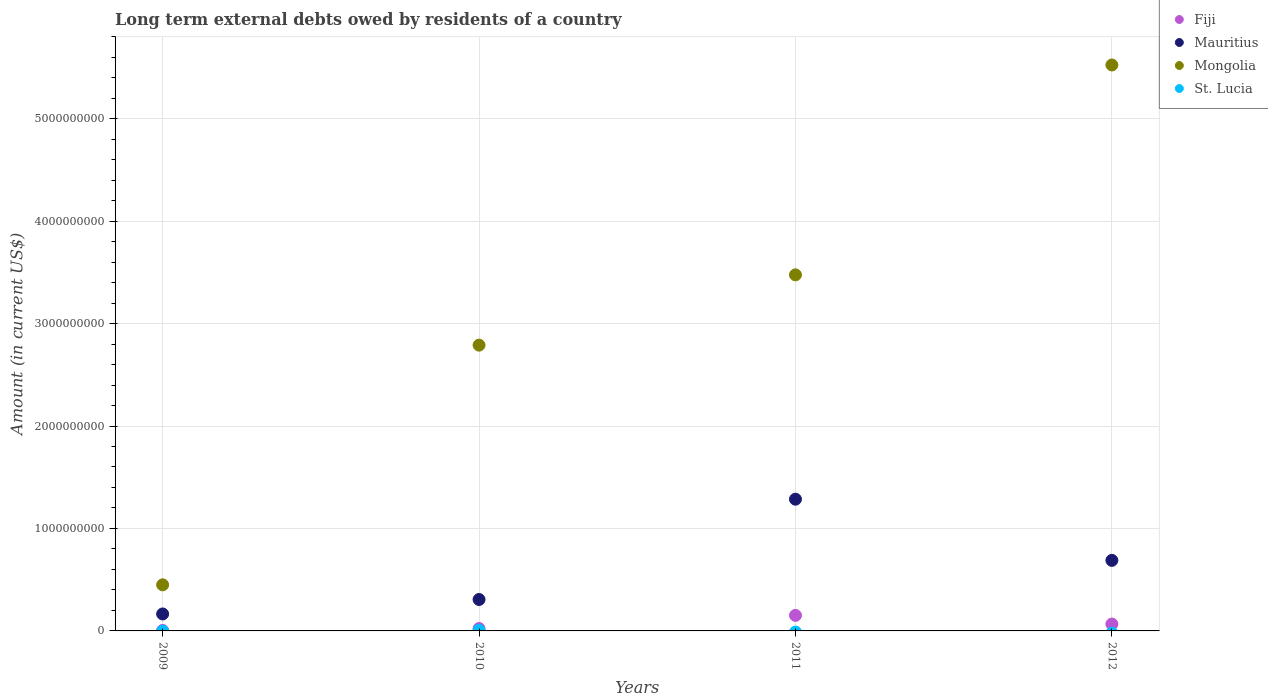How many different coloured dotlines are there?
Provide a succinct answer. 4. Is the number of dotlines equal to the number of legend labels?
Give a very brief answer. No. Across all years, what is the maximum amount of long-term external debts owed by residents in St. Lucia?
Your answer should be very brief. 6.51e+06. Across all years, what is the minimum amount of long-term external debts owed by residents in Mongolia?
Offer a very short reply. 4.50e+08. In which year was the amount of long-term external debts owed by residents in St. Lucia maximum?
Your answer should be very brief. 2010. What is the total amount of long-term external debts owed by residents in Fiji in the graph?
Keep it short and to the point. 2.47e+08. What is the difference between the amount of long-term external debts owed by residents in Fiji in 2009 and that in 2012?
Offer a terse response. -6.22e+07. What is the difference between the amount of long-term external debts owed by residents in St. Lucia in 2011 and the amount of long-term external debts owed by residents in Mauritius in 2009?
Keep it short and to the point. -1.65e+08. What is the average amount of long-term external debts owed by residents in St. Lucia per year?
Offer a terse response. 1.63e+06. In the year 2009, what is the difference between the amount of long-term external debts owed by residents in Fiji and amount of long-term external debts owed by residents in Mauritius?
Your response must be concise. -1.61e+08. In how many years, is the amount of long-term external debts owed by residents in Mauritius greater than 2000000000 US$?
Your response must be concise. 0. What is the ratio of the amount of long-term external debts owed by residents in Mauritius in 2011 to that in 2012?
Keep it short and to the point. 1.87. Is the difference between the amount of long-term external debts owed by residents in Fiji in 2009 and 2010 greater than the difference between the amount of long-term external debts owed by residents in Mauritius in 2009 and 2010?
Provide a succinct answer. Yes. What is the difference between the highest and the second highest amount of long-term external debts owed by residents in Mauritius?
Provide a succinct answer. 5.97e+08. What is the difference between the highest and the lowest amount of long-term external debts owed by residents in Mongolia?
Your answer should be very brief. 5.07e+09. In how many years, is the amount of long-term external debts owed by residents in St. Lucia greater than the average amount of long-term external debts owed by residents in St. Lucia taken over all years?
Your answer should be compact. 1. Is the sum of the amount of long-term external debts owed by residents in Mongolia in 2010 and 2012 greater than the maximum amount of long-term external debts owed by residents in Fiji across all years?
Your response must be concise. Yes. Is it the case that in every year, the sum of the amount of long-term external debts owed by residents in St. Lucia and amount of long-term external debts owed by residents in Mongolia  is greater than the amount of long-term external debts owed by residents in Fiji?
Ensure brevity in your answer.  Yes. Does the amount of long-term external debts owed by residents in St. Lucia monotonically increase over the years?
Your answer should be very brief. No. Is the amount of long-term external debts owed by residents in St. Lucia strictly less than the amount of long-term external debts owed by residents in Fiji over the years?
Provide a short and direct response. Yes. How many dotlines are there?
Your answer should be very brief. 4. How many years are there in the graph?
Give a very brief answer. 4. How many legend labels are there?
Your answer should be compact. 4. What is the title of the graph?
Your answer should be compact. Long term external debts owed by residents of a country. Does "Guyana" appear as one of the legend labels in the graph?
Ensure brevity in your answer.  No. What is the label or title of the X-axis?
Provide a short and direct response. Years. What is the Amount (in current US$) of Fiji in 2009?
Provide a succinct answer. 4.86e+06. What is the Amount (in current US$) of Mauritius in 2009?
Give a very brief answer. 1.65e+08. What is the Amount (in current US$) of Mongolia in 2009?
Offer a very short reply. 4.50e+08. What is the Amount (in current US$) in Fiji in 2010?
Keep it short and to the point. 2.35e+07. What is the Amount (in current US$) of Mauritius in 2010?
Keep it short and to the point. 3.07e+08. What is the Amount (in current US$) in Mongolia in 2010?
Your answer should be very brief. 2.79e+09. What is the Amount (in current US$) in St. Lucia in 2010?
Give a very brief answer. 6.51e+06. What is the Amount (in current US$) of Fiji in 2011?
Provide a short and direct response. 1.52e+08. What is the Amount (in current US$) of Mauritius in 2011?
Provide a succinct answer. 1.29e+09. What is the Amount (in current US$) in Mongolia in 2011?
Provide a succinct answer. 3.48e+09. What is the Amount (in current US$) of St. Lucia in 2011?
Make the answer very short. 0. What is the Amount (in current US$) of Fiji in 2012?
Make the answer very short. 6.71e+07. What is the Amount (in current US$) in Mauritius in 2012?
Provide a succinct answer. 6.89e+08. What is the Amount (in current US$) of Mongolia in 2012?
Your answer should be very brief. 5.52e+09. What is the Amount (in current US$) of St. Lucia in 2012?
Give a very brief answer. 0. Across all years, what is the maximum Amount (in current US$) in Fiji?
Your answer should be very brief. 1.52e+08. Across all years, what is the maximum Amount (in current US$) in Mauritius?
Your response must be concise. 1.29e+09. Across all years, what is the maximum Amount (in current US$) in Mongolia?
Offer a very short reply. 5.52e+09. Across all years, what is the maximum Amount (in current US$) of St. Lucia?
Provide a short and direct response. 6.51e+06. Across all years, what is the minimum Amount (in current US$) in Fiji?
Make the answer very short. 4.86e+06. Across all years, what is the minimum Amount (in current US$) in Mauritius?
Your answer should be very brief. 1.65e+08. Across all years, what is the minimum Amount (in current US$) in Mongolia?
Your response must be concise. 4.50e+08. Across all years, what is the minimum Amount (in current US$) of St. Lucia?
Keep it short and to the point. 0. What is the total Amount (in current US$) of Fiji in the graph?
Offer a terse response. 2.47e+08. What is the total Amount (in current US$) of Mauritius in the graph?
Your response must be concise. 2.45e+09. What is the total Amount (in current US$) of Mongolia in the graph?
Keep it short and to the point. 1.22e+1. What is the total Amount (in current US$) of St. Lucia in the graph?
Your answer should be compact. 6.51e+06. What is the difference between the Amount (in current US$) of Fiji in 2009 and that in 2010?
Offer a very short reply. -1.86e+07. What is the difference between the Amount (in current US$) of Mauritius in 2009 and that in 2010?
Provide a succinct answer. -1.41e+08. What is the difference between the Amount (in current US$) of Mongolia in 2009 and that in 2010?
Make the answer very short. -2.34e+09. What is the difference between the Amount (in current US$) of Fiji in 2009 and that in 2011?
Ensure brevity in your answer.  -1.47e+08. What is the difference between the Amount (in current US$) in Mauritius in 2009 and that in 2011?
Your answer should be compact. -1.12e+09. What is the difference between the Amount (in current US$) of Mongolia in 2009 and that in 2011?
Your answer should be compact. -3.03e+09. What is the difference between the Amount (in current US$) of Fiji in 2009 and that in 2012?
Offer a very short reply. -6.22e+07. What is the difference between the Amount (in current US$) of Mauritius in 2009 and that in 2012?
Keep it short and to the point. -5.23e+08. What is the difference between the Amount (in current US$) in Mongolia in 2009 and that in 2012?
Your response must be concise. -5.07e+09. What is the difference between the Amount (in current US$) of Fiji in 2010 and that in 2011?
Your response must be concise. -1.28e+08. What is the difference between the Amount (in current US$) of Mauritius in 2010 and that in 2011?
Your response must be concise. -9.79e+08. What is the difference between the Amount (in current US$) in Mongolia in 2010 and that in 2011?
Offer a very short reply. -6.86e+08. What is the difference between the Amount (in current US$) of Fiji in 2010 and that in 2012?
Ensure brevity in your answer.  -4.36e+07. What is the difference between the Amount (in current US$) of Mauritius in 2010 and that in 2012?
Offer a terse response. -3.82e+08. What is the difference between the Amount (in current US$) in Mongolia in 2010 and that in 2012?
Offer a terse response. -2.73e+09. What is the difference between the Amount (in current US$) of Fiji in 2011 and that in 2012?
Your answer should be compact. 8.47e+07. What is the difference between the Amount (in current US$) of Mauritius in 2011 and that in 2012?
Provide a succinct answer. 5.97e+08. What is the difference between the Amount (in current US$) in Mongolia in 2011 and that in 2012?
Offer a terse response. -2.05e+09. What is the difference between the Amount (in current US$) in Fiji in 2009 and the Amount (in current US$) in Mauritius in 2010?
Ensure brevity in your answer.  -3.02e+08. What is the difference between the Amount (in current US$) in Fiji in 2009 and the Amount (in current US$) in Mongolia in 2010?
Your response must be concise. -2.78e+09. What is the difference between the Amount (in current US$) of Fiji in 2009 and the Amount (in current US$) of St. Lucia in 2010?
Your answer should be compact. -1.65e+06. What is the difference between the Amount (in current US$) in Mauritius in 2009 and the Amount (in current US$) in Mongolia in 2010?
Ensure brevity in your answer.  -2.62e+09. What is the difference between the Amount (in current US$) of Mauritius in 2009 and the Amount (in current US$) of St. Lucia in 2010?
Make the answer very short. 1.59e+08. What is the difference between the Amount (in current US$) of Mongolia in 2009 and the Amount (in current US$) of St. Lucia in 2010?
Provide a short and direct response. 4.43e+08. What is the difference between the Amount (in current US$) in Fiji in 2009 and the Amount (in current US$) in Mauritius in 2011?
Ensure brevity in your answer.  -1.28e+09. What is the difference between the Amount (in current US$) in Fiji in 2009 and the Amount (in current US$) in Mongolia in 2011?
Offer a terse response. -3.47e+09. What is the difference between the Amount (in current US$) of Mauritius in 2009 and the Amount (in current US$) of Mongolia in 2011?
Your answer should be very brief. -3.31e+09. What is the difference between the Amount (in current US$) of Fiji in 2009 and the Amount (in current US$) of Mauritius in 2012?
Offer a very short reply. -6.84e+08. What is the difference between the Amount (in current US$) in Fiji in 2009 and the Amount (in current US$) in Mongolia in 2012?
Make the answer very short. -5.52e+09. What is the difference between the Amount (in current US$) of Mauritius in 2009 and the Amount (in current US$) of Mongolia in 2012?
Your answer should be very brief. -5.36e+09. What is the difference between the Amount (in current US$) in Fiji in 2010 and the Amount (in current US$) in Mauritius in 2011?
Make the answer very short. -1.26e+09. What is the difference between the Amount (in current US$) in Fiji in 2010 and the Amount (in current US$) in Mongolia in 2011?
Offer a terse response. -3.45e+09. What is the difference between the Amount (in current US$) in Mauritius in 2010 and the Amount (in current US$) in Mongolia in 2011?
Offer a very short reply. -3.17e+09. What is the difference between the Amount (in current US$) of Fiji in 2010 and the Amount (in current US$) of Mauritius in 2012?
Provide a succinct answer. -6.65e+08. What is the difference between the Amount (in current US$) of Fiji in 2010 and the Amount (in current US$) of Mongolia in 2012?
Offer a very short reply. -5.50e+09. What is the difference between the Amount (in current US$) in Mauritius in 2010 and the Amount (in current US$) in Mongolia in 2012?
Your response must be concise. -5.22e+09. What is the difference between the Amount (in current US$) of Fiji in 2011 and the Amount (in current US$) of Mauritius in 2012?
Your answer should be compact. -5.37e+08. What is the difference between the Amount (in current US$) in Fiji in 2011 and the Amount (in current US$) in Mongolia in 2012?
Provide a short and direct response. -5.37e+09. What is the difference between the Amount (in current US$) in Mauritius in 2011 and the Amount (in current US$) in Mongolia in 2012?
Make the answer very short. -4.24e+09. What is the average Amount (in current US$) of Fiji per year?
Provide a short and direct response. 6.18e+07. What is the average Amount (in current US$) of Mauritius per year?
Ensure brevity in your answer.  6.12e+08. What is the average Amount (in current US$) of Mongolia per year?
Make the answer very short. 3.06e+09. What is the average Amount (in current US$) of St. Lucia per year?
Offer a very short reply. 1.63e+06. In the year 2009, what is the difference between the Amount (in current US$) of Fiji and Amount (in current US$) of Mauritius?
Your answer should be compact. -1.61e+08. In the year 2009, what is the difference between the Amount (in current US$) of Fiji and Amount (in current US$) of Mongolia?
Keep it short and to the point. -4.45e+08. In the year 2009, what is the difference between the Amount (in current US$) in Mauritius and Amount (in current US$) in Mongolia?
Your response must be concise. -2.84e+08. In the year 2010, what is the difference between the Amount (in current US$) of Fiji and Amount (in current US$) of Mauritius?
Make the answer very short. -2.83e+08. In the year 2010, what is the difference between the Amount (in current US$) of Fiji and Amount (in current US$) of Mongolia?
Keep it short and to the point. -2.77e+09. In the year 2010, what is the difference between the Amount (in current US$) in Fiji and Amount (in current US$) in St. Lucia?
Ensure brevity in your answer.  1.69e+07. In the year 2010, what is the difference between the Amount (in current US$) in Mauritius and Amount (in current US$) in Mongolia?
Provide a short and direct response. -2.48e+09. In the year 2010, what is the difference between the Amount (in current US$) of Mauritius and Amount (in current US$) of St. Lucia?
Ensure brevity in your answer.  3.00e+08. In the year 2010, what is the difference between the Amount (in current US$) in Mongolia and Amount (in current US$) in St. Lucia?
Your answer should be very brief. 2.78e+09. In the year 2011, what is the difference between the Amount (in current US$) of Fiji and Amount (in current US$) of Mauritius?
Offer a terse response. -1.13e+09. In the year 2011, what is the difference between the Amount (in current US$) of Fiji and Amount (in current US$) of Mongolia?
Your answer should be compact. -3.32e+09. In the year 2011, what is the difference between the Amount (in current US$) in Mauritius and Amount (in current US$) in Mongolia?
Give a very brief answer. -2.19e+09. In the year 2012, what is the difference between the Amount (in current US$) in Fiji and Amount (in current US$) in Mauritius?
Your answer should be very brief. -6.22e+08. In the year 2012, what is the difference between the Amount (in current US$) of Fiji and Amount (in current US$) of Mongolia?
Your response must be concise. -5.46e+09. In the year 2012, what is the difference between the Amount (in current US$) in Mauritius and Amount (in current US$) in Mongolia?
Ensure brevity in your answer.  -4.84e+09. What is the ratio of the Amount (in current US$) in Fiji in 2009 to that in 2010?
Give a very brief answer. 0.21. What is the ratio of the Amount (in current US$) of Mauritius in 2009 to that in 2010?
Offer a terse response. 0.54. What is the ratio of the Amount (in current US$) of Mongolia in 2009 to that in 2010?
Offer a very short reply. 0.16. What is the ratio of the Amount (in current US$) in Fiji in 2009 to that in 2011?
Your answer should be compact. 0.03. What is the ratio of the Amount (in current US$) in Mauritius in 2009 to that in 2011?
Keep it short and to the point. 0.13. What is the ratio of the Amount (in current US$) in Mongolia in 2009 to that in 2011?
Your answer should be very brief. 0.13. What is the ratio of the Amount (in current US$) of Fiji in 2009 to that in 2012?
Provide a succinct answer. 0.07. What is the ratio of the Amount (in current US$) of Mauritius in 2009 to that in 2012?
Make the answer very short. 0.24. What is the ratio of the Amount (in current US$) in Mongolia in 2009 to that in 2012?
Your response must be concise. 0.08. What is the ratio of the Amount (in current US$) in Fiji in 2010 to that in 2011?
Your answer should be very brief. 0.15. What is the ratio of the Amount (in current US$) of Mauritius in 2010 to that in 2011?
Give a very brief answer. 0.24. What is the ratio of the Amount (in current US$) in Mongolia in 2010 to that in 2011?
Provide a succinct answer. 0.8. What is the ratio of the Amount (in current US$) of Fiji in 2010 to that in 2012?
Make the answer very short. 0.35. What is the ratio of the Amount (in current US$) in Mauritius in 2010 to that in 2012?
Keep it short and to the point. 0.45. What is the ratio of the Amount (in current US$) of Mongolia in 2010 to that in 2012?
Give a very brief answer. 0.51. What is the ratio of the Amount (in current US$) in Fiji in 2011 to that in 2012?
Your answer should be compact. 2.26. What is the ratio of the Amount (in current US$) in Mauritius in 2011 to that in 2012?
Provide a succinct answer. 1.87. What is the ratio of the Amount (in current US$) of Mongolia in 2011 to that in 2012?
Your answer should be very brief. 0.63. What is the difference between the highest and the second highest Amount (in current US$) in Fiji?
Your answer should be very brief. 8.47e+07. What is the difference between the highest and the second highest Amount (in current US$) of Mauritius?
Give a very brief answer. 5.97e+08. What is the difference between the highest and the second highest Amount (in current US$) in Mongolia?
Your answer should be very brief. 2.05e+09. What is the difference between the highest and the lowest Amount (in current US$) in Fiji?
Offer a very short reply. 1.47e+08. What is the difference between the highest and the lowest Amount (in current US$) of Mauritius?
Offer a terse response. 1.12e+09. What is the difference between the highest and the lowest Amount (in current US$) of Mongolia?
Provide a succinct answer. 5.07e+09. What is the difference between the highest and the lowest Amount (in current US$) of St. Lucia?
Provide a succinct answer. 6.51e+06. 